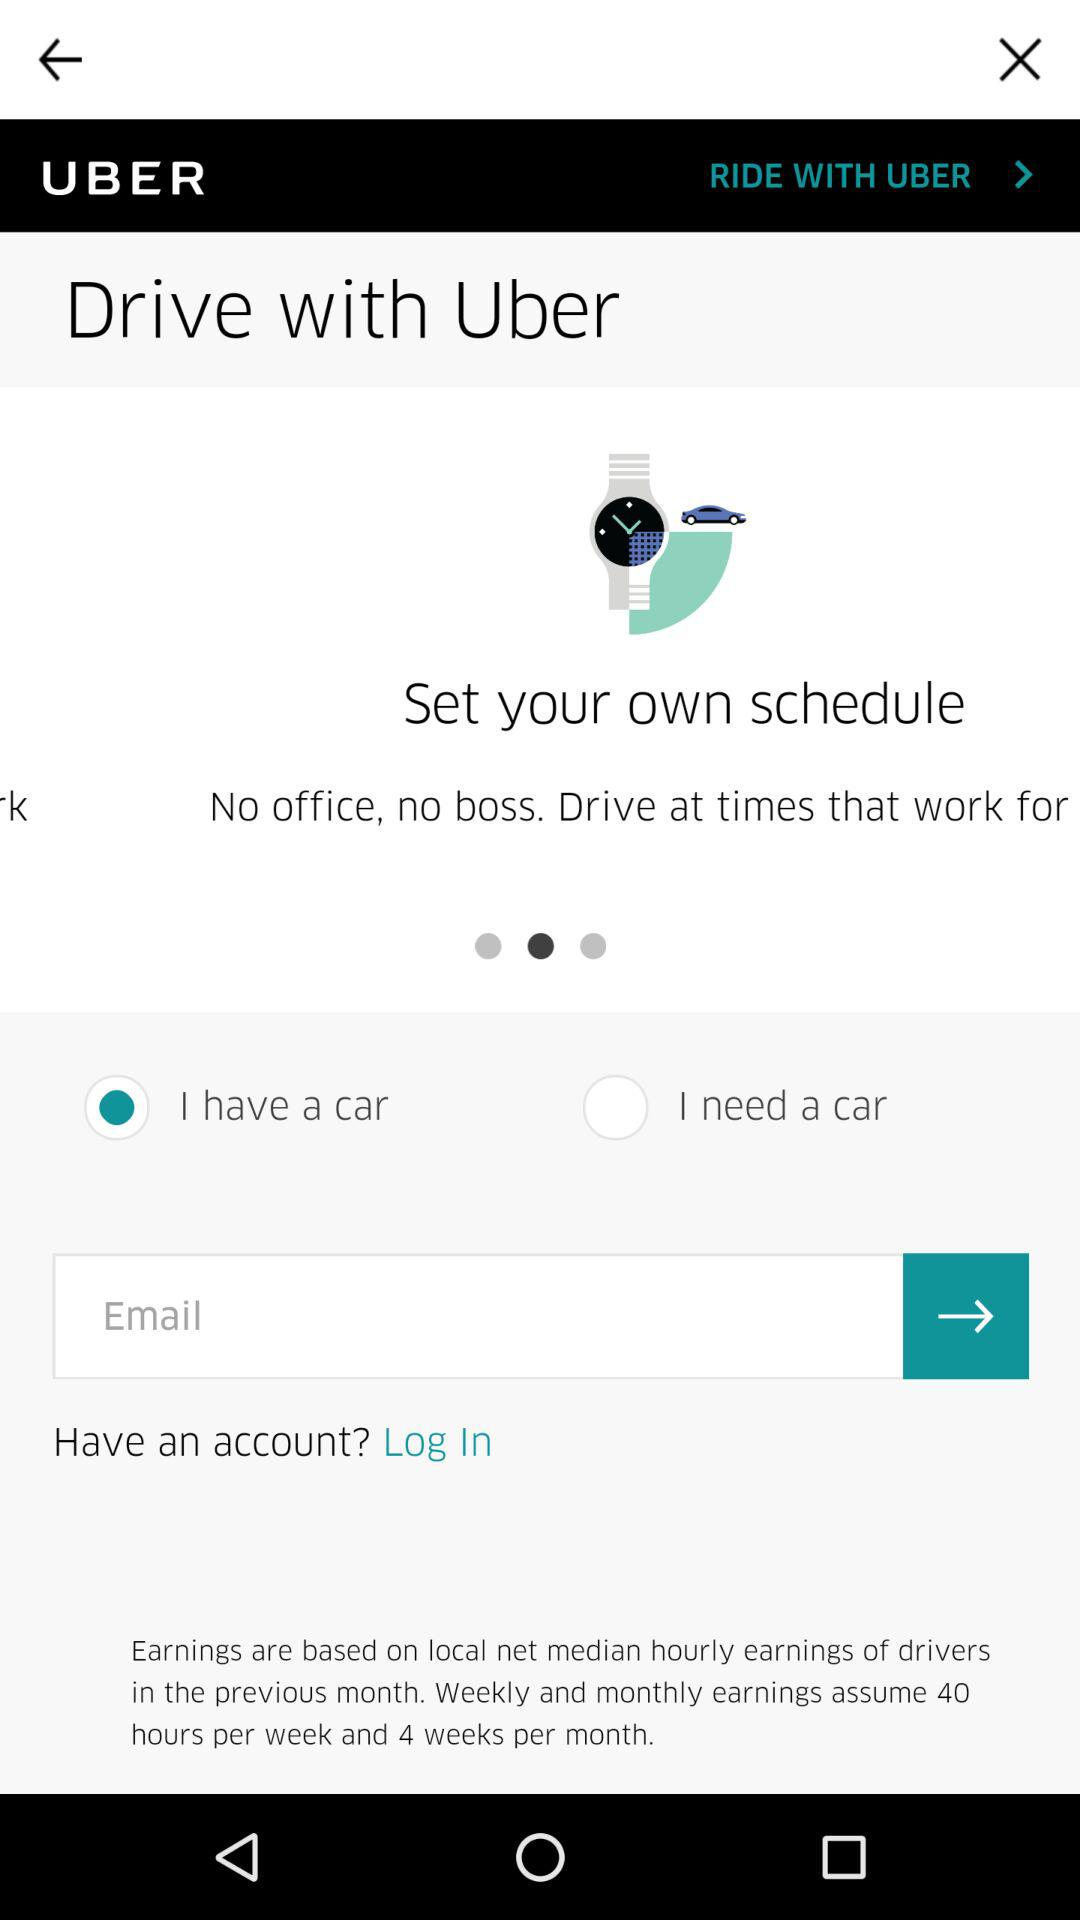Which of the options was chosen? The chosen option was "I have a car". 